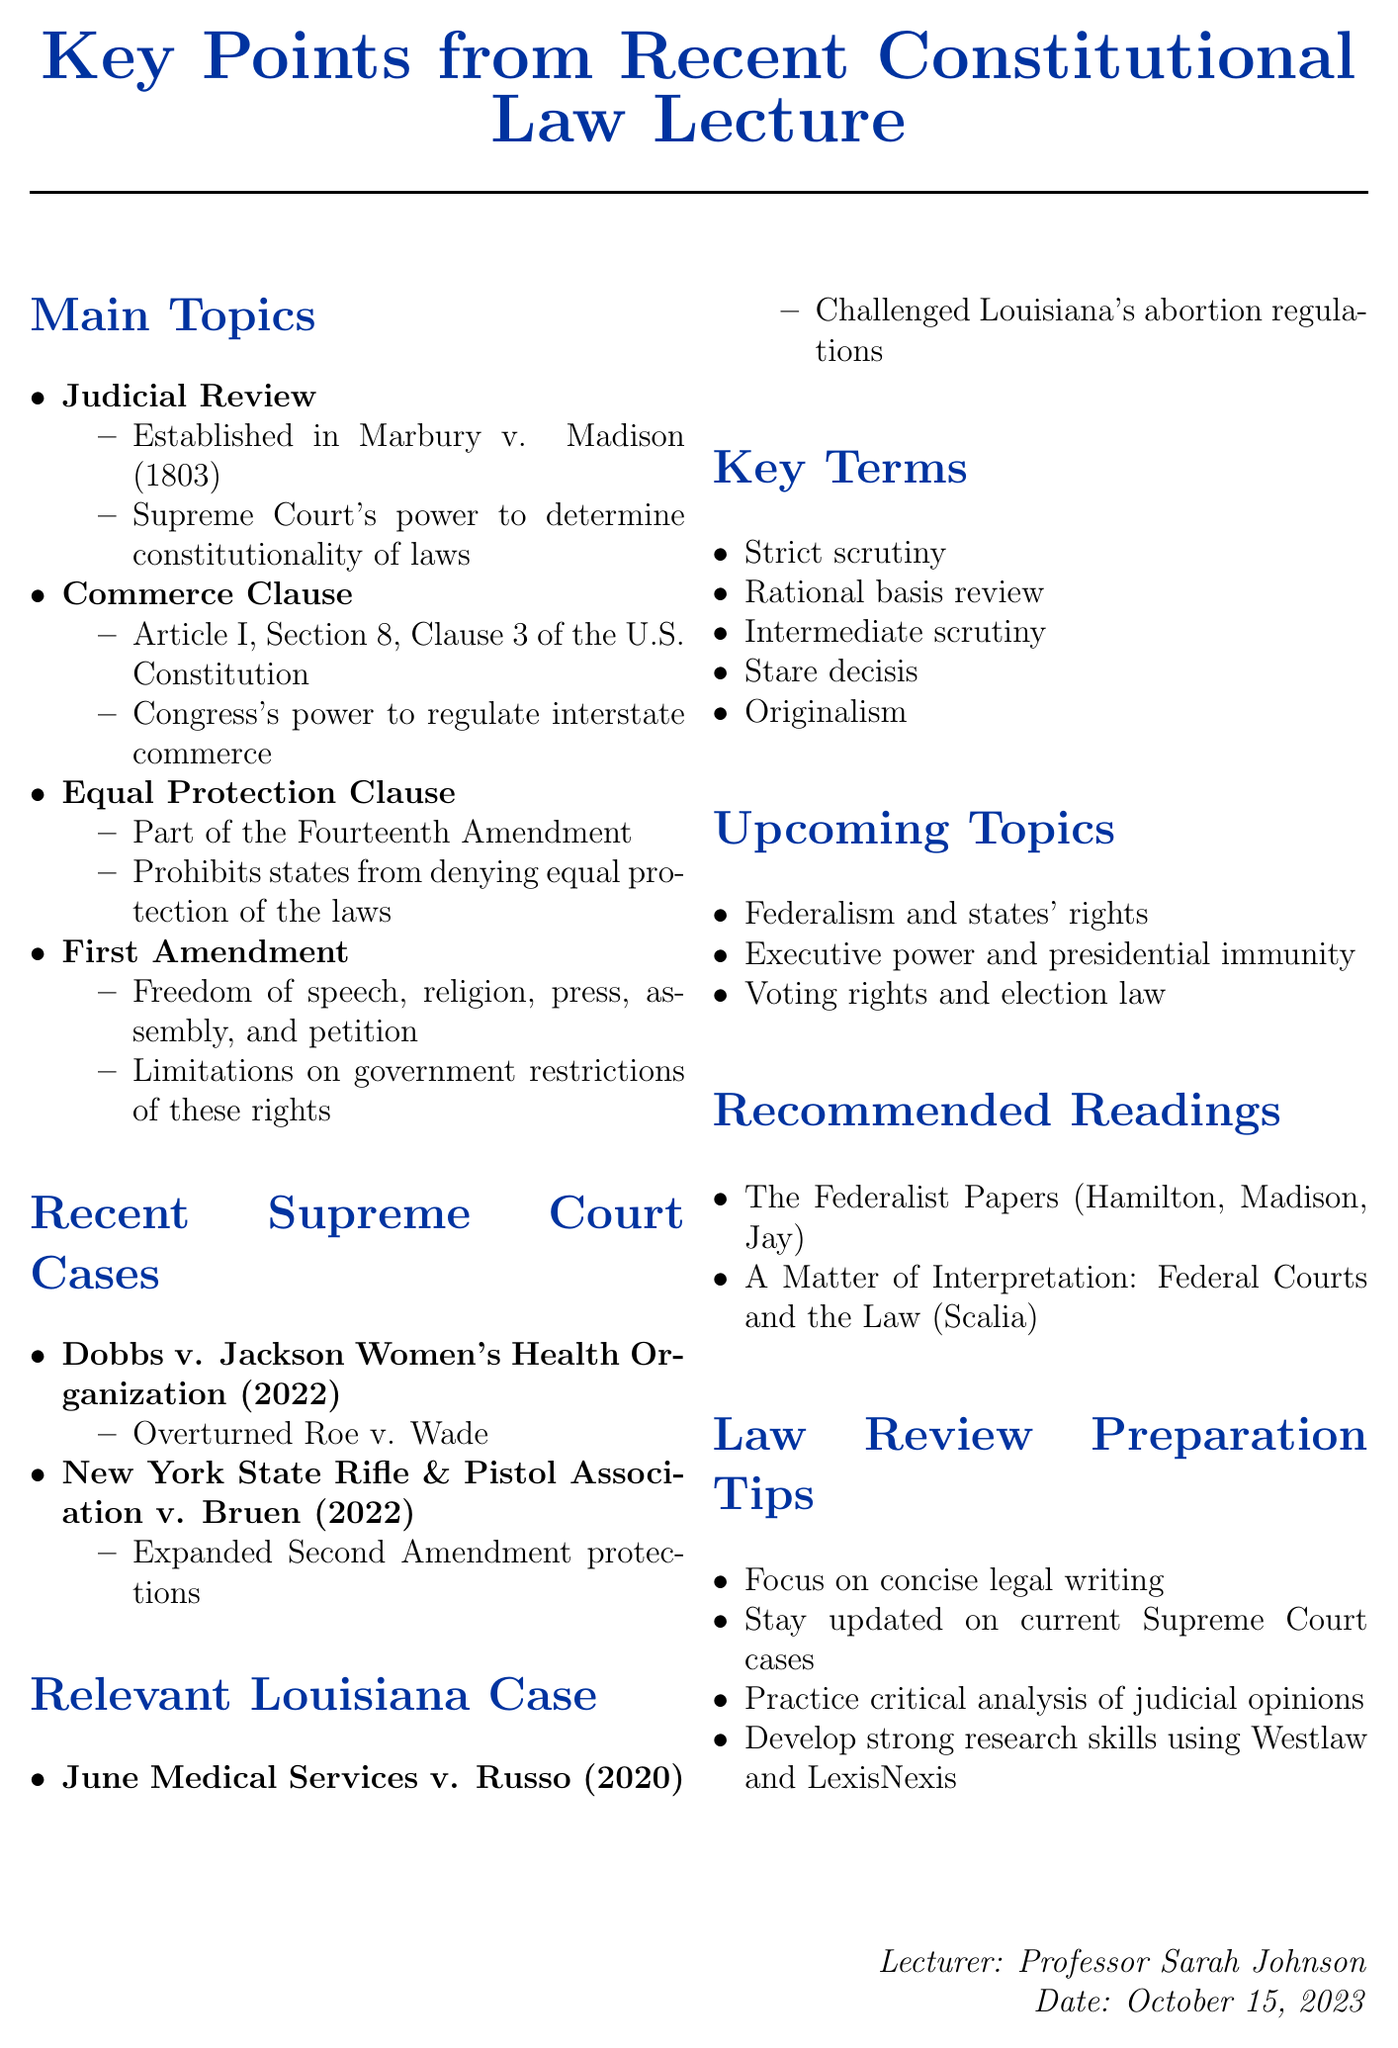What is the title of the memo? The title is provided in the document's header, summarizing the key content discussed in the lecture.
Answer: Key Points from Recent Constitutional Law Lecture Who is the lecturer of the recent Constitutional Law lecture? The document specifies the name of the lecturer, indicating who delivered the lecture.
Answer: Professor Sarah Johnson What year was Dobbs v. Jackson Women's Health Organization decided? The document includes the year of the decision for each case mentioned.
Answer: 2022 Which amendment includes the Equal Protection Clause? The document references the specific amendment that contains the clause discussed in relation to discrimination.
Answer: Fourteenth Amendment What is one of the upcoming topics listed in the memo? The memo outlines topics that will be covered in future lectures, providing a glimpse into the upcoming curriculum.
Answer: Federalism and states' rights What are the recommended readings titled? The document provides a list of readings, specifying their titles and authors relevant to the course material.
Answer: The Federalist Papers What is one of the key terms mentioned in the memo? The memo lists important legal terms that are relevant to constitutional law.
Answer: Strict scrutiny In what case was the concept of Judicial Review established? The memo connects the key topic of Judicial Review to a specific case that established its principle.
Answer: Marbury v. Madison What is a tip for preparing for Law Review mentioned in the memo? The document includes practical advice for students aiming to participate in Law Review, focusing on what skills to develop.
Answer: Focus on concise legal writing 